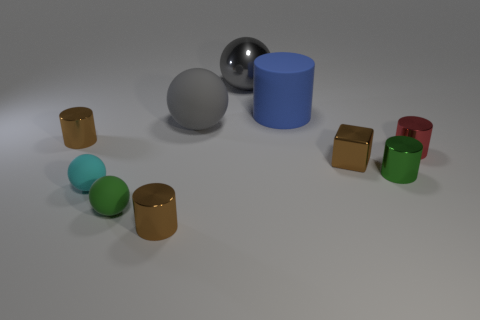Subtract all green spheres. How many spheres are left? 3 Subtract all red cylinders. How many cylinders are left? 4 Subtract all red spheres. How many brown cylinders are left? 2 Subtract 1 cylinders. How many cylinders are left? 4 Subtract 0 yellow cubes. How many objects are left? 10 Subtract all blocks. How many objects are left? 9 Subtract all cyan cylinders. Subtract all cyan balls. How many cylinders are left? 5 Subtract all tiny green shiny cylinders. Subtract all tiny brown cubes. How many objects are left? 8 Add 1 small metallic cubes. How many small metallic cubes are left? 2 Add 1 big shiny objects. How many big shiny objects exist? 2 